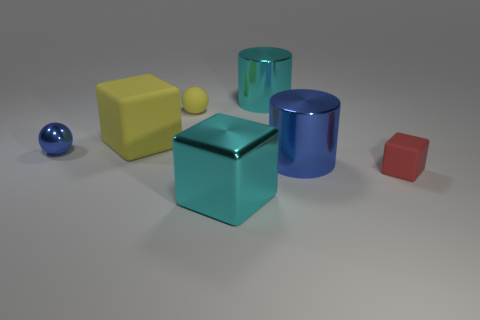There is a large rubber object; is its color the same as the tiny rubber object on the left side of the red cube?
Ensure brevity in your answer.  Yes. There is a block right of the blue metallic cylinder; what is it made of?
Offer a terse response. Rubber. What is the size of the yellow matte object that is the same shape as the tiny blue thing?
Offer a terse response. Small. How many large gray cylinders have the same material as the tiny yellow sphere?
Make the answer very short. 0. What number of small metallic balls are the same color as the tiny rubber sphere?
Provide a succinct answer. 0. What number of objects are either blue things that are on the right side of the small yellow matte ball or matte things that are behind the small red matte thing?
Your response must be concise. 3. Is the number of matte blocks that are to the left of the tiny red cube less than the number of big matte cubes?
Keep it short and to the point. No. Is there a cyan block that has the same size as the metallic ball?
Offer a terse response. No. What color is the metal cube?
Give a very brief answer. Cyan. Do the blue ball and the yellow rubber sphere have the same size?
Give a very brief answer. Yes. 